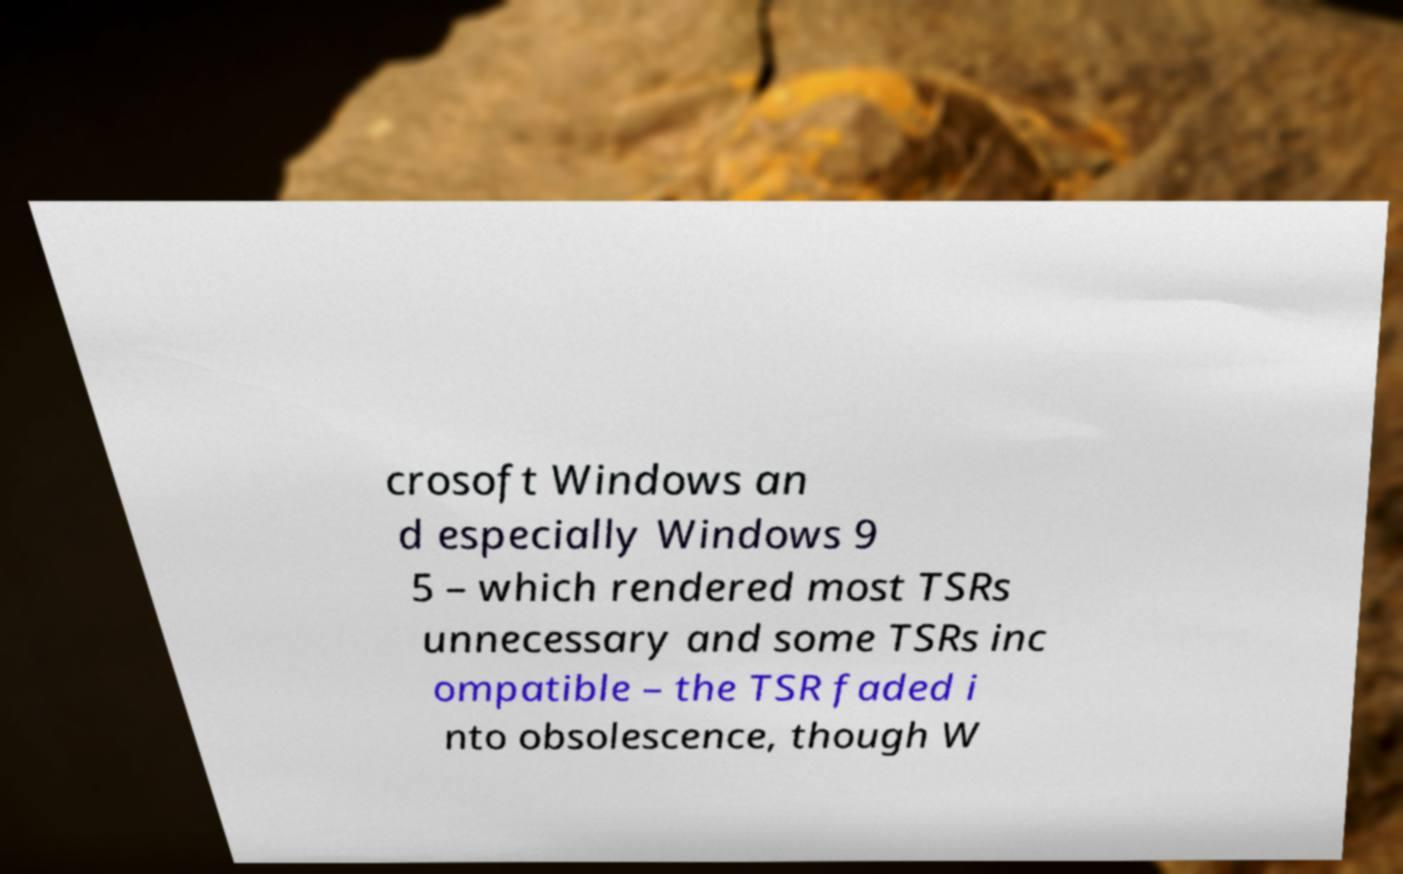For documentation purposes, I need the text within this image transcribed. Could you provide that? crosoft Windows an d especially Windows 9 5 – which rendered most TSRs unnecessary and some TSRs inc ompatible – the TSR faded i nto obsolescence, though W 